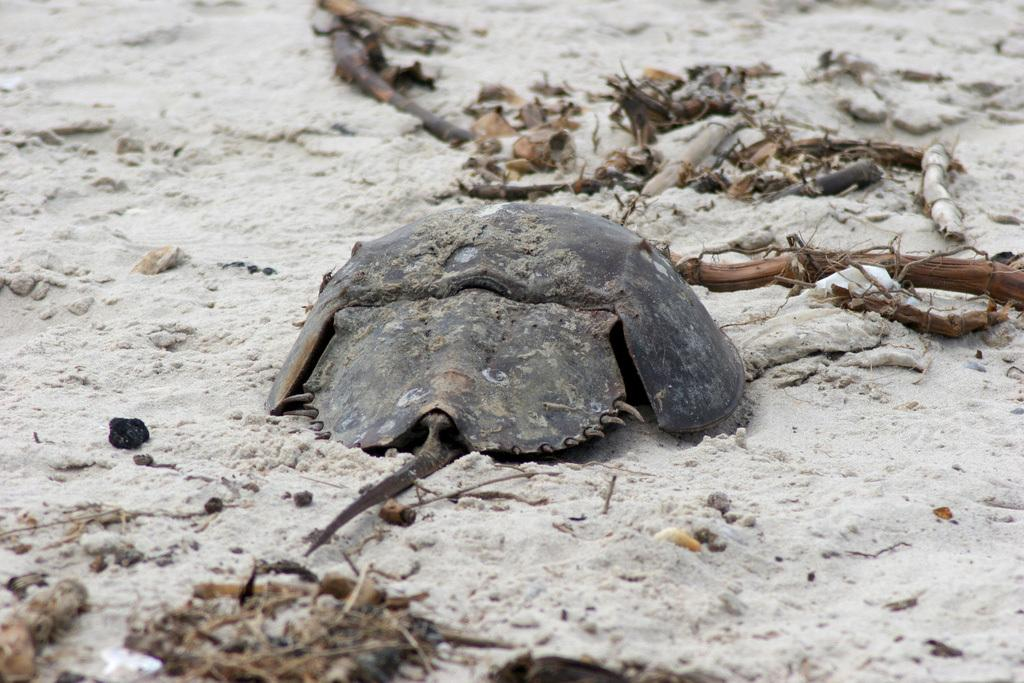What type of animal is in the image? There is a reptile in the image. What color is the reptile? The reptile is brown in color. Where is the reptile located in the image? The reptile is on the sand. What type of garden tool is being used by the reptile in the image? There is no garden tool or any indication of gardening activity in the image. 